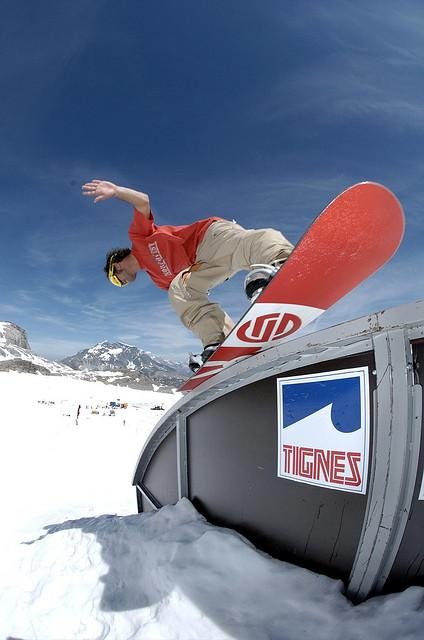What is this type of snowboard trick called?

Choices:
A) grinding
B) nollie
C) 360 flip
D) ollie grinding 